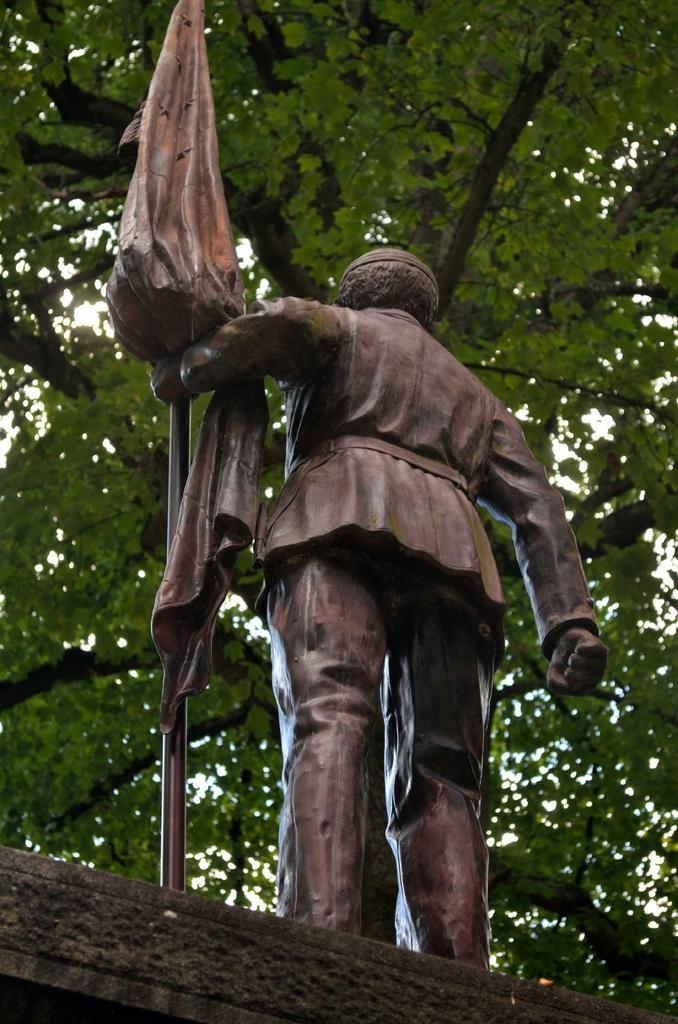Please provide a concise description of this image. In this image I can see a statue of a person holding a pole to which there is a cloth on the concrete surface. I can see the statue is brown in color. In the background I can see the tree and the sky through the gaps in between the leafs. 